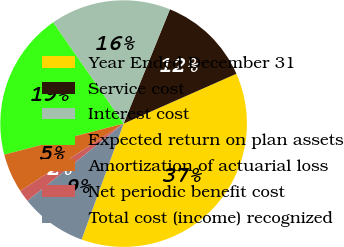<chart> <loc_0><loc_0><loc_500><loc_500><pie_chart><fcel>Year Ended December 31<fcel>Service cost<fcel>Interest cost<fcel>Expected return on plan assets<fcel>Amortization of actuarial loss<fcel>Net periodic benefit cost<fcel>Total cost (income) recognized<nl><fcel>37.15%<fcel>12.25%<fcel>15.81%<fcel>19.37%<fcel>5.14%<fcel>1.58%<fcel>8.7%<nl></chart> 